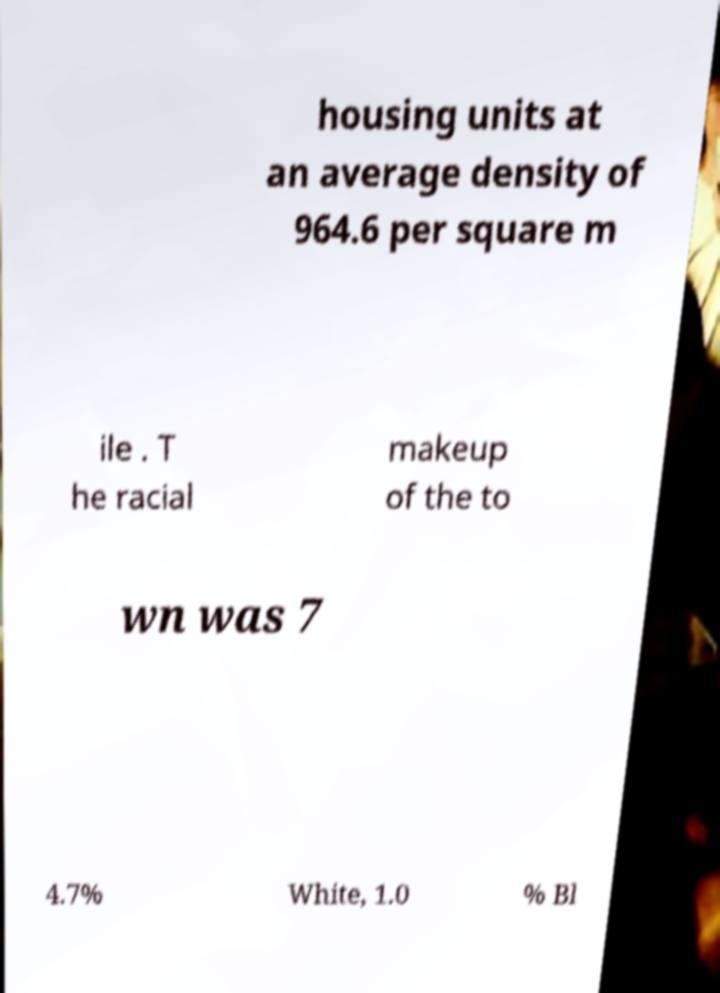Could you assist in decoding the text presented in this image and type it out clearly? housing units at an average density of 964.6 per square m ile . T he racial makeup of the to wn was 7 4.7% White, 1.0 % Bl 